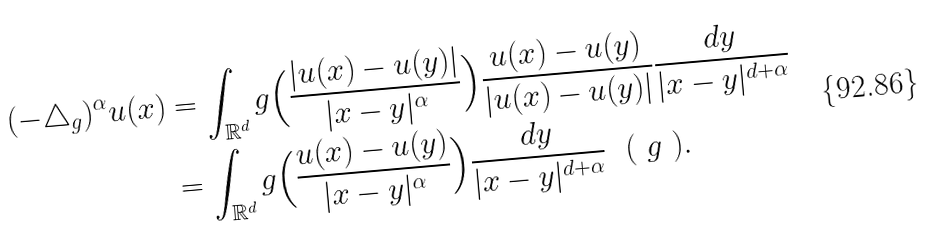<formula> <loc_0><loc_0><loc_500><loc_500>( - \triangle _ { g } ) ^ { \alpha } u ( x ) & = \int _ { \mathbb { R } ^ { d } } g \Big { ( } \frac { | u ( x ) - u ( y ) | } { | x - y | ^ { \alpha } } \Big { ) } \frac { u ( x ) - u ( y ) } { | u ( x ) - u ( y ) | } \frac { d y } { | x - y | ^ { d + \alpha } } \\ & = \int _ { \mathbb { R } ^ { d } } g \Big { ( } \frac { u ( x ) - u ( y ) } { | x - y | ^ { \alpha } } \Big { ) } \frac { d y } { | x - y | ^ { d + \alpha } } \ \ ( \ g \ ) .</formula> 